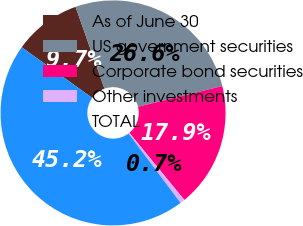Convert chart to OTSL. <chart><loc_0><loc_0><loc_500><loc_500><pie_chart><fcel>As of June 30<fcel>US government securities<fcel>Corporate bond securities<fcel>Other investments<fcel>TOTAL<nl><fcel>9.67%<fcel>26.57%<fcel>17.91%<fcel>0.68%<fcel>45.16%<nl></chart> 